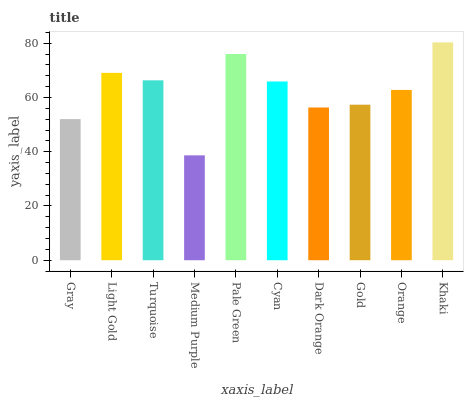Is Medium Purple the minimum?
Answer yes or no. Yes. Is Khaki the maximum?
Answer yes or no. Yes. Is Light Gold the minimum?
Answer yes or no. No. Is Light Gold the maximum?
Answer yes or no. No. Is Light Gold greater than Gray?
Answer yes or no. Yes. Is Gray less than Light Gold?
Answer yes or no. Yes. Is Gray greater than Light Gold?
Answer yes or no. No. Is Light Gold less than Gray?
Answer yes or no. No. Is Cyan the high median?
Answer yes or no. Yes. Is Orange the low median?
Answer yes or no. Yes. Is Light Gold the high median?
Answer yes or no. No. Is Cyan the low median?
Answer yes or no. No. 